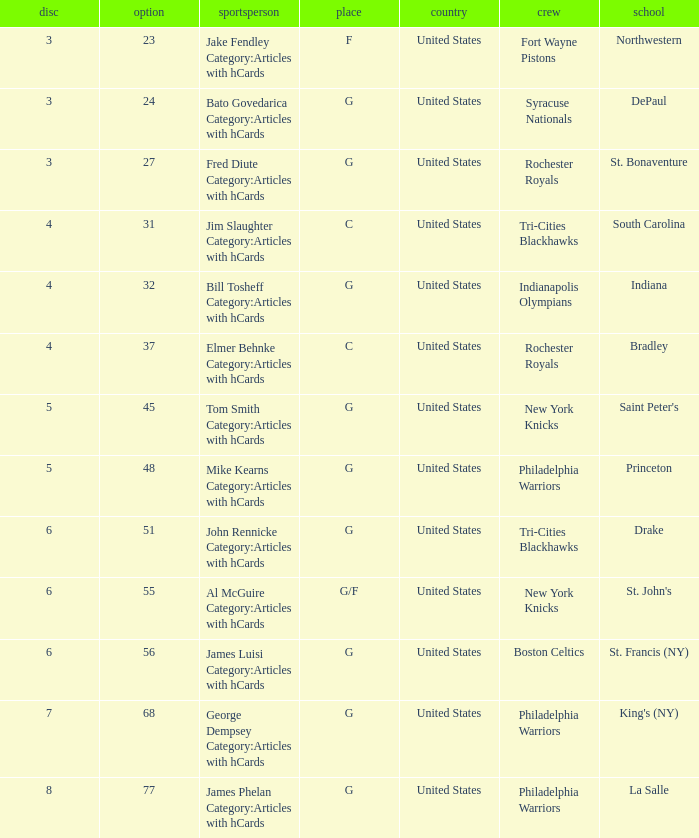What is the lowest pick number for players from king's (ny)? 68.0. 